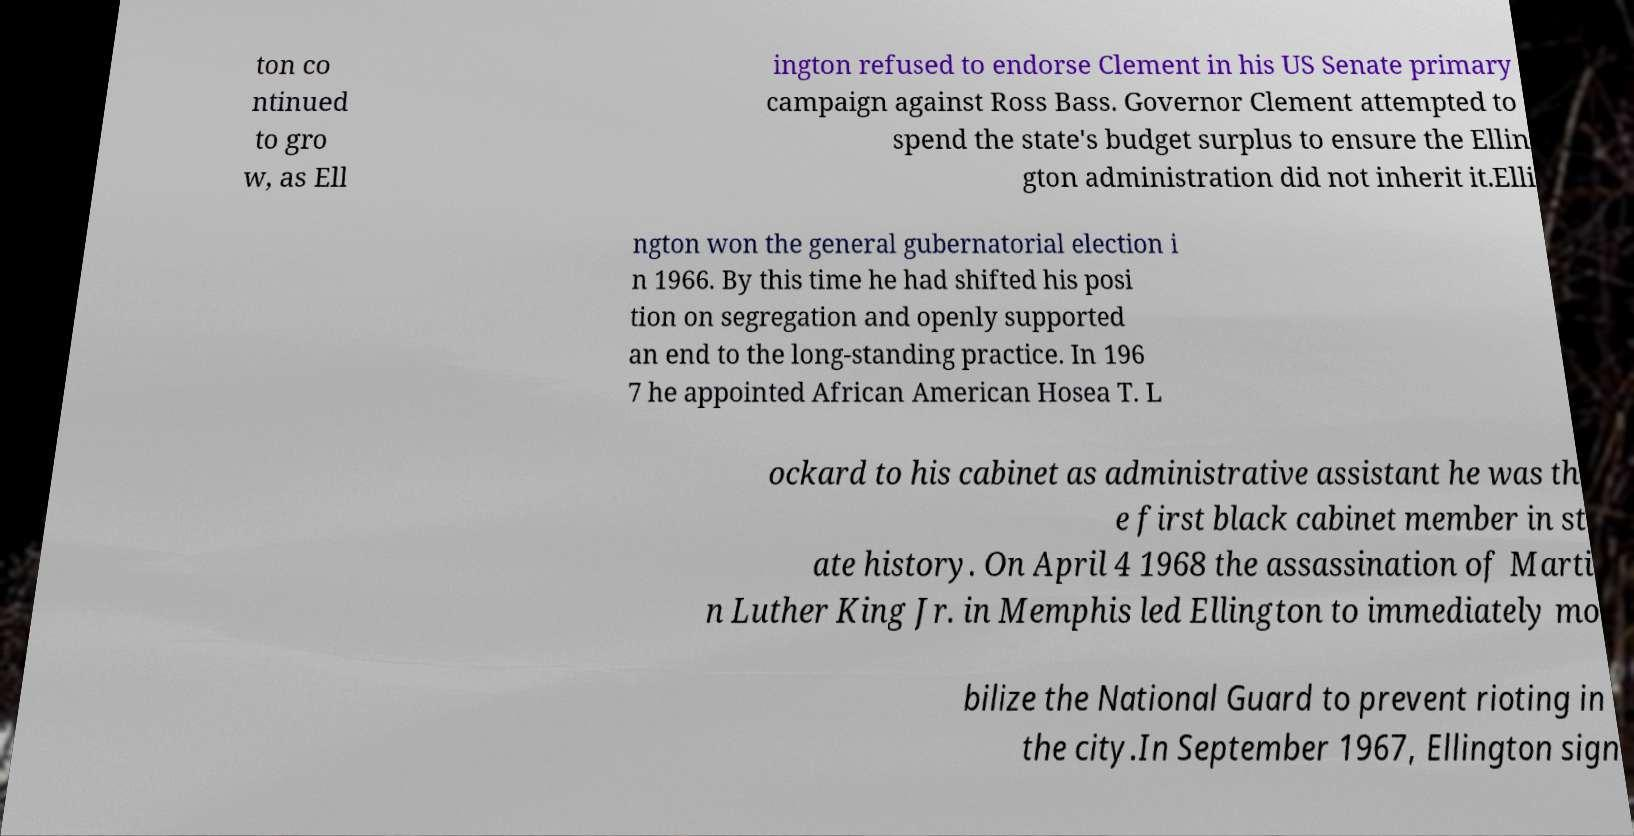Could you assist in decoding the text presented in this image and type it out clearly? ton co ntinued to gro w, as Ell ington refused to endorse Clement in his US Senate primary campaign against Ross Bass. Governor Clement attempted to spend the state's budget surplus to ensure the Ellin gton administration did not inherit it.Elli ngton won the general gubernatorial election i n 1966. By this time he had shifted his posi tion on segregation and openly supported an end to the long-standing practice. In 196 7 he appointed African American Hosea T. L ockard to his cabinet as administrative assistant he was th e first black cabinet member in st ate history. On April 4 1968 the assassination of Marti n Luther King Jr. in Memphis led Ellington to immediately mo bilize the National Guard to prevent rioting in the city.In September 1967, Ellington sign 